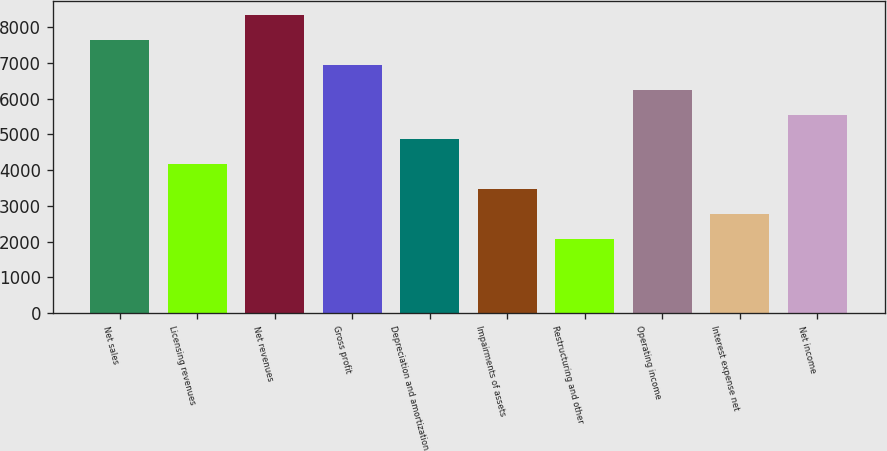Convert chart to OTSL. <chart><loc_0><loc_0><loc_500><loc_500><bar_chart><fcel>Net sales<fcel>Licensing revenues<fcel>Net revenues<fcel>Gross profit<fcel>Depreciation and amortization<fcel>Impairments of assets<fcel>Restructuring and other<fcel>Operating income<fcel>Interest expense net<fcel>Net income<nl><fcel>7639.34<fcel>4167.64<fcel>8333.68<fcel>6945<fcel>4861.98<fcel>3473.3<fcel>2084.62<fcel>6250.66<fcel>2778.96<fcel>5556.32<nl></chart> 